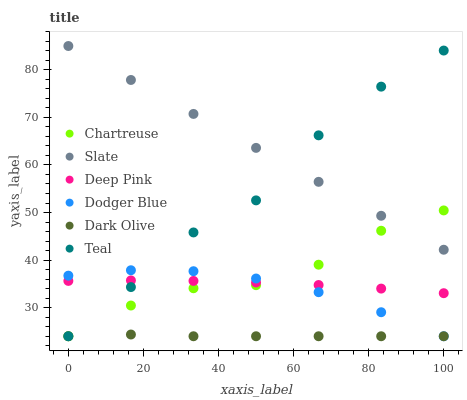Does Dark Olive have the minimum area under the curve?
Answer yes or no. Yes. Does Slate have the maximum area under the curve?
Answer yes or no. Yes. Does Slate have the minimum area under the curve?
Answer yes or no. No. Does Dark Olive have the maximum area under the curve?
Answer yes or no. No. Is Slate the smoothest?
Answer yes or no. Yes. Is Teal the roughest?
Answer yes or no. Yes. Is Dark Olive the smoothest?
Answer yes or no. No. Is Dark Olive the roughest?
Answer yes or no. No. Does Dark Olive have the lowest value?
Answer yes or no. Yes. Does Slate have the lowest value?
Answer yes or no. No. Does Slate have the highest value?
Answer yes or no. Yes. Does Dark Olive have the highest value?
Answer yes or no. No. Is Deep Pink less than Slate?
Answer yes or no. Yes. Is Slate greater than Dodger Blue?
Answer yes or no. Yes. Does Dark Olive intersect Teal?
Answer yes or no. Yes. Is Dark Olive less than Teal?
Answer yes or no. No. Is Dark Olive greater than Teal?
Answer yes or no. No. Does Deep Pink intersect Slate?
Answer yes or no. No. 